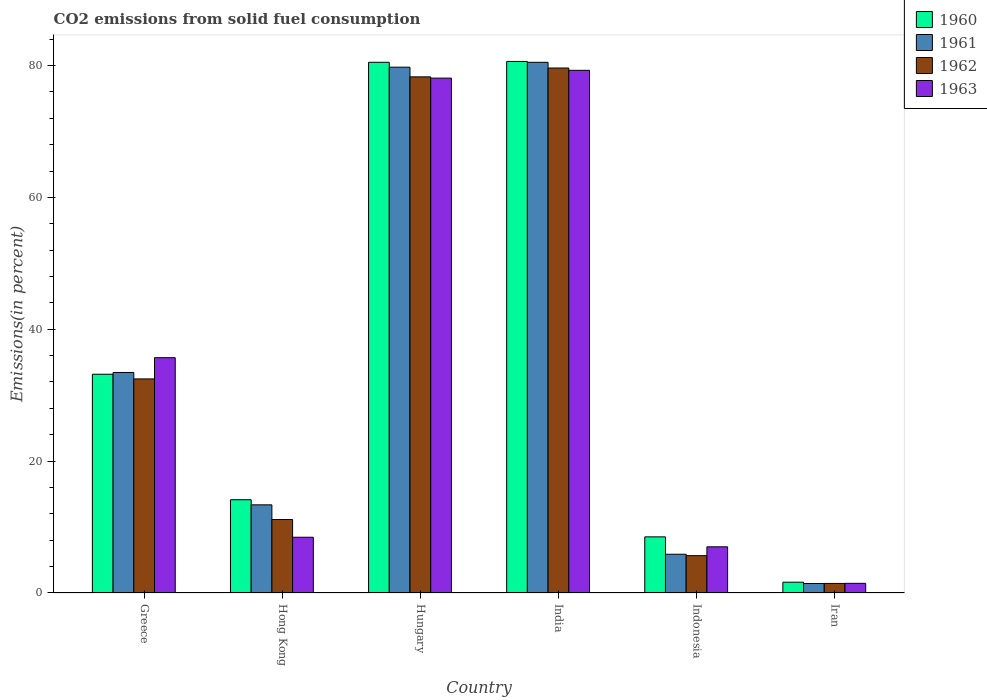How many different coloured bars are there?
Your response must be concise. 4. How many groups of bars are there?
Your response must be concise. 6. How many bars are there on the 5th tick from the left?
Your answer should be compact. 4. How many bars are there on the 5th tick from the right?
Keep it short and to the point. 4. What is the label of the 2nd group of bars from the left?
Give a very brief answer. Hong Kong. In how many cases, is the number of bars for a given country not equal to the number of legend labels?
Give a very brief answer. 0. What is the total CO2 emitted in 1962 in Hungary?
Make the answer very short. 78.28. Across all countries, what is the maximum total CO2 emitted in 1961?
Your response must be concise. 80.49. Across all countries, what is the minimum total CO2 emitted in 1963?
Offer a terse response. 1.46. In which country was the total CO2 emitted in 1962 minimum?
Your answer should be compact. Iran. What is the total total CO2 emitted in 1961 in the graph?
Provide a succinct answer. 214.36. What is the difference between the total CO2 emitted in 1960 in Greece and that in Hungary?
Keep it short and to the point. -47.31. What is the difference between the total CO2 emitted in 1961 in Iran and the total CO2 emitted in 1962 in Greece?
Make the answer very short. -31.03. What is the average total CO2 emitted in 1962 per country?
Your response must be concise. 34.77. What is the difference between the total CO2 emitted of/in 1960 and total CO2 emitted of/in 1961 in Greece?
Your response must be concise. -0.27. In how many countries, is the total CO2 emitted in 1962 greater than 28 %?
Provide a succinct answer. 3. What is the ratio of the total CO2 emitted in 1961 in Hungary to that in Iran?
Give a very brief answer. 55.57. Is the total CO2 emitted in 1961 in Greece less than that in Iran?
Keep it short and to the point. No. What is the difference between the highest and the second highest total CO2 emitted in 1963?
Your answer should be compact. -42.4. What is the difference between the highest and the lowest total CO2 emitted in 1963?
Ensure brevity in your answer.  77.81. In how many countries, is the total CO2 emitted in 1960 greater than the average total CO2 emitted in 1960 taken over all countries?
Provide a short and direct response. 2. Is it the case that in every country, the sum of the total CO2 emitted in 1960 and total CO2 emitted in 1962 is greater than the sum of total CO2 emitted in 1961 and total CO2 emitted in 1963?
Your response must be concise. No. What does the 1st bar from the left in India represents?
Make the answer very short. 1960. Is it the case that in every country, the sum of the total CO2 emitted in 1960 and total CO2 emitted in 1962 is greater than the total CO2 emitted in 1961?
Your response must be concise. Yes. How many bars are there?
Offer a terse response. 24. Are all the bars in the graph horizontal?
Offer a very short reply. No. How many countries are there in the graph?
Give a very brief answer. 6. Does the graph contain any zero values?
Offer a very short reply. No. Does the graph contain grids?
Your response must be concise. No. How many legend labels are there?
Offer a very short reply. 4. What is the title of the graph?
Your answer should be compact. CO2 emissions from solid fuel consumption. What is the label or title of the X-axis?
Provide a short and direct response. Country. What is the label or title of the Y-axis?
Offer a terse response. Emissions(in percent). What is the Emissions(in percent) of 1960 in Greece?
Keep it short and to the point. 33.18. What is the Emissions(in percent) of 1961 in Greece?
Provide a succinct answer. 33.45. What is the Emissions(in percent) in 1962 in Greece?
Offer a very short reply. 32.47. What is the Emissions(in percent) in 1963 in Greece?
Provide a short and direct response. 35.69. What is the Emissions(in percent) in 1960 in Hong Kong?
Your answer should be compact. 14.14. What is the Emissions(in percent) in 1961 in Hong Kong?
Give a very brief answer. 13.37. What is the Emissions(in percent) of 1962 in Hong Kong?
Provide a succinct answer. 11.14. What is the Emissions(in percent) of 1963 in Hong Kong?
Make the answer very short. 8.46. What is the Emissions(in percent) in 1960 in Hungary?
Offer a very short reply. 80.49. What is the Emissions(in percent) in 1961 in Hungary?
Make the answer very short. 79.75. What is the Emissions(in percent) in 1962 in Hungary?
Give a very brief answer. 78.28. What is the Emissions(in percent) in 1963 in Hungary?
Offer a terse response. 78.09. What is the Emissions(in percent) of 1960 in India?
Offer a terse response. 80.62. What is the Emissions(in percent) in 1961 in India?
Offer a very short reply. 80.49. What is the Emissions(in percent) of 1962 in India?
Your answer should be compact. 79.62. What is the Emissions(in percent) of 1963 in India?
Provide a succinct answer. 79.27. What is the Emissions(in percent) of 1960 in Indonesia?
Your answer should be compact. 8.51. What is the Emissions(in percent) of 1961 in Indonesia?
Offer a terse response. 5.88. What is the Emissions(in percent) of 1962 in Indonesia?
Offer a terse response. 5.66. What is the Emissions(in percent) of 1963 in Indonesia?
Offer a terse response. 7. What is the Emissions(in percent) in 1960 in Iran?
Provide a succinct answer. 1.64. What is the Emissions(in percent) of 1961 in Iran?
Your answer should be compact. 1.44. What is the Emissions(in percent) in 1962 in Iran?
Your answer should be compact. 1.45. What is the Emissions(in percent) of 1963 in Iran?
Offer a terse response. 1.46. Across all countries, what is the maximum Emissions(in percent) of 1960?
Your answer should be very brief. 80.62. Across all countries, what is the maximum Emissions(in percent) of 1961?
Provide a succinct answer. 80.49. Across all countries, what is the maximum Emissions(in percent) in 1962?
Your response must be concise. 79.62. Across all countries, what is the maximum Emissions(in percent) in 1963?
Give a very brief answer. 79.27. Across all countries, what is the minimum Emissions(in percent) of 1960?
Offer a very short reply. 1.64. Across all countries, what is the minimum Emissions(in percent) in 1961?
Your response must be concise. 1.44. Across all countries, what is the minimum Emissions(in percent) of 1962?
Make the answer very short. 1.45. Across all countries, what is the minimum Emissions(in percent) of 1963?
Offer a very short reply. 1.46. What is the total Emissions(in percent) in 1960 in the graph?
Offer a very short reply. 218.58. What is the total Emissions(in percent) in 1961 in the graph?
Your answer should be compact. 214.36. What is the total Emissions(in percent) of 1962 in the graph?
Your response must be concise. 208.62. What is the total Emissions(in percent) in 1963 in the graph?
Provide a succinct answer. 209.97. What is the difference between the Emissions(in percent) of 1960 in Greece and that in Hong Kong?
Your response must be concise. 19.03. What is the difference between the Emissions(in percent) of 1961 in Greece and that in Hong Kong?
Offer a terse response. 20.08. What is the difference between the Emissions(in percent) in 1962 in Greece and that in Hong Kong?
Your answer should be compact. 21.32. What is the difference between the Emissions(in percent) in 1963 in Greece and that in Hong Kong?
Provide a short and direct response. 27.23. What is the difference between the Emissions(in percent) in 1960 in Greece and that in Hungary?
Provide a succinct answer. -47.31. What is the difference between the Emissions(in percent) of 1961 in Greece and that in Hungary?
Keep it short and to the point. -46.3. What is the difference between the Emissions(in percent) of 1962 in Greece and that in Hungary?
Your answer should be compact. -45.81. What is the difference between the Emissions(in percent) of 1963 in Greece and that in Hungary?
Your answer should be very brief. -42.4. What is the difference between the Emissions(in percent) in 1960 in Greece and that in India?
Give a very brief answer. -47.44. What is the difference between the Emissions(in percent) in 1961 in Greece and that in India?
Offer a terse response. -47.04. What is the difference between the Emissions(in percent) in 1962 in Greece and that in India?
Provide a short and direct response. -47.15. What is the difference between the Emissions(in percent) of 1963 in Greece and that in India?
Offer a terse response. -43.58. What is the difference between the Emissions(in percent) of 1960 in Greece and that in Indonesia?
Give a very brief answer. 24.66. What is the difference between the Emissions(in percent) in 1961 in Greece and that in Indonesia?
Your answer should be very brief. 27.57. What is the difference between the Emissions(in percent) in 1962 in Greece and that in Indonesia?
Offer a very short reply. 26.81. What is the difference between the Emissions(in percent) in 1963 in Greece and that in Indonesia?
Provide a short and direct response. 28.69. What is the difference between the Emissions(in percent) of 1960 in Greece and that in Iran?
Your answer should be compact. 31.54. What is the difference between the Emissions(in percent) of 1961 in Greece and that in Iran?
Ensure brevity in your answer.  32.01. What is the difference between the Emissions(in percent) in 1962 in Greece and that in Iran?
Provide a short and direct response. 31.02. What is the difference between the Emissions(in percent) in 1963 in Greece and that in Iran?
Provide a succinct answer. 34.22. What is the difference between the Emissions(in percent) in 1960 in Hong Kong and that in Hungary?
Your answer should be very brief. -66.35. What is the difference between the Emissions(in percent) in 1961 in Hong Kong and that in Hungary?
Provide a short and direct response. -66.38. What is the difference between the Emissions(in percent) of 1962 in Hong Kong and that in Hungary?
Offer a terse response. -67.13. What is the difference between the Emissions(in percent) in 1963 in Hong Kong and that in Hungary?
Ensure brevity in your answer.  -69.63. What is the difference between the Emissions(in percent) in 1960 in Hong Kong and that in India?
Offer a terse response. -66.47. What is the difference between the Emissions(in percent) in 1961 in Hong Kong and that in India?
Offer a very short reply. -67.12. What is the difference between the Emissions(in percent) in 1962 in Hong Kong and that in India?
Keep it short and to the point. -68.47. What is the difference between the Emissions(in percent) in 1963 in Hong Kong and that in India?
Make the answer very short. -70.82. What is the difference between the Emissions(in percent) of 1960 in Hong Kong and that in Indonesia?
Offer a terse response. 5.63. What is the difference between the Emissions(in percent) of 1961 in Hong Kong and that in Indonesia?
Your answer should be very brief. 7.49. What is the difference between the Emissions(in percent) of 1962 in Hong Kong and that in Indonesia?
Make the answer very short. 5.48. What is the difference between the Emissions(in percent) of 1963 in Hong Kong and that in Indonesia?
Provide a succinct answer. 1.45. What is the difference between the Emissions(in percent) in 1960 in Hong Kong and that in Iran?
Give a very brief answer. 12.51. What is the difference between the Emissions(in percent) in 1961 in Hong Kong and that in Iran?
Ensure brevity in your answer.  11.93. What is the difference between the Emissions(in percent) of 1962 in Hong Kong and that in Iran?
Offer a very short reply. 9.7. What is the difference between the Emissions(in percent) in 1963 in Hong Kong and that in Iran?
Your answer should be very brief. 6.99. What is the difference between the Emissions(in percent) of 1960 in Hungary and that in India?
Provide a short and direct response. -0.13. What is the difference between the Emissions(in percent) of 1961 in Hungary and that in India?
Make the answer very short. -0.74. What is the difference between the Emissions(in percent) in 1962 in Hungary and that in India?
Offer a terse response. -1.34. What is the difference between the Emissions(in percent) in 1963 in Hungary and that in India?
Keep it short and to the point. -1.18. What is the difference between the Emissions(in percent) in 1960 in Hungary and that in Indonesia?
Make the answer very short. 71.98. What is the difference between the Emissions(in percent) of 1961 in Hungary and that in Indonesia?
Keep it short and to the point. 73.87. What is the difference between the Emissions(in percent) of 1962 in Hungary and that in Indonesia?
Offer a terse response. 72.62. What is the difference between the Emissions(in percent) in 1963 in Hungary and that in Indonesia?
Your answer should be very brief. 71.09. What is the difference between the Emissions(in percent) in 1960 in Hungary and that in Iran?
Your response must be concise. 78.85. What is the difference between the Emissions(in percent) in 1961 in Hungary and that in Iran?
Your response must be concise. 78.31. What is the difference between the Emissions(in percent) in 1962 in Hungary and that in Iran?
Keep it short and to the point. 76.83. What is the difference between the Emissions(in percent) of 1963 in Hungary and that in Iran?
Give a very brief answer. 76.62. What is the difference between the Emissions(in percent) in 1960 in India and that in Indonesia?
Offer a terse response. 72.1. What is the difference between the Emissions(in percent) of 1961 in India and that in Indonesia?
Your response must be concise. 74.61. What is the difference between the Emissions(in percent) of 1962 in India and that in Indonesia?
Your answer should be compact. 73.96. What is the difference between the Emissions(in percent) in 1963 in India and that in Indonesia?
Provide a short and direct response. 72.27. What is the difference between the Emissions(in percent) of 1960 in India and that in Iran?
Offer a very short reply. 78.98. What is the difference between the Emissions(in percent) in 1961 in India and that in Iran?
Keep it short and to the point. 79.05. What is the difference between the Emissions(in percent) in 1962 in India and that in Iran?
Offer a terse response. 78.17. What is the difference between the Emissions(in percent) of 1963 in India and that in Iran?
Offer a terse response. 77.81. What is the difference between the Emissions(in percent) of 1960 in Indonesia and that in Iran?
Your response must be concise. 6.88. What is the difference between the Emissions(in percent) of 1961 in Indonesia and that in Iran?
Your answer should be very brief. 4.44. What is the difference between the Emissions(in percent) in 1962 in Indonesia and that in Iran?
Your answer should be very brief. 4.21. What is the difference between the Emissions(in percent) in 1963 in Indonesia and that in Iran?
Offer a very short reply. 5.54. What is the difference between the Emissions(in percent) in 1960 in Greece and the Emissions(in percent) in 1961 in Hong Kong?
Offer a very short reply. 19.81. What is the difference between the Emissions(in percent) of 1960 in Greece and the Emissions(in percent) of 1962 in Hong Kong?
Ensure brevity in your answer.  22.03. What is the difference between the Emissions(in percent) in 1960 in Greece and the Emissions(in percent) in 1963 in Hong Kong?
Ensure brevity in your answer.  24.72. What is the difference between the Emissions(in percent) in 1961 in Greece and the Emissions(in percent) in 1962 in Hong Kong?
Your response must be concise. 22.3. What is the difference between the Emissions(in percent) in 1961 in Greece and the Emissions(in percent) in 1963 in Hong Kong?
Provide a short and direct response. 24.99. What is the difference between the Emissions(in percent) in 1962 in Greece and the Emissions(in percent) in 1963 in Hong Kong?
Keep it short and to the point. 24.01. What is the difference between the Emissions(in percent) of 1960 in Greece and the Emissions(in percent) of 1961 in Hungary?
Your answer should be very brief. -46.57. What is the difference between the Emissions(in percent) in 1960 in Greece and the Emissions(in percent) in 1962 in Hungary?
Give a very brief answer. -45.1. What is the difference between the Emissions(in percent) of 1960 in Greece and the Emissions(in percent) of 1963 in Hungary?
Offer a very short reply. -44.91. What is the difference between the Emissions(in percent) of 1961 in Greece and the Emissions(in percent) of 1962 in Hungary?
Make the answer very short. -44.83. What is the difference between the Emissions(in percent) in 1961 in Greece and the Emissions(in percent) in 1963 in Hungary?
Make the answer very short. -44.64. What is the difference between the Emissions(in percent) of 1962 in Greece and the Emissions(in percent) of 1963 in Hungary?
Keep it short and to the point. -45.62. What is the difference between the Emissions(in percent) in 1960 in Greece and the Emissions(in percent) in 1961 in India?
Offer a very short reply. -47.31. What is the difference between the Emissions(in percent) of 1960 in Greece and the Emissions(in percent) of 1962 in India?
Your answer should be compact. -46.44. What is the difference between the Emissions(in percent) in 1960 in Greece and the Emissions(in percent) in 1963 in India?
Ensure brevity in your answer.  -46.09. What is the difference between the Emissions(in percent) of 1961 in Greece and the Emissions(in percent) of 1962 in India?
Provide a succinct answer. -46.17. What is the difference between the Emissions(in percent) in 1961 in Greece and the Emissions(in percent) in 1963 in India?
Offer a terse response. -45.83. What is the difference between the Emissions(in percent) in 1962 in Greece and the Emissions(in percent) in 1963 in India?
Offer a terse response. -46.8. What is the difference between the Emissions(in percent) in 1960 in Greece and the Emissions(in percent) in 1961 in Indonesia?
Your answer should be compact. 27.3. What is the difference between the Emissions(in percent) in 1960 in Greece and the Emissions(in percent) in 1962 in Indonesia?
Offer a terse response. 27.52. What is the difference between the Emissions(in percent) of 1960 in Greece and the Emissions(in percent) of 1963 in Indonesia?
Offer a very short reply. 26.18. What is the difference between the Emissions(in percent) in 1961 in Greece and the Emissions(in percent) in 1962 in Indonesia?
Offer a very short reply. 27.78. What is the difference between the Emissions(in percent) in 1961 in Greece and the Emissions(in percent) in 1963 in Indonesia?
Provide a succinct answer. 26.44. What is the difference between the Emissions(in percent) in 1962 in Greece and the Emissions(in percent) in 1963 in Indonesia?
Provide a short and direct response. 25.47. What is the difference between the Emissions(in percent) in 1960 in Greece and the Emissions(in percent) in 1961 in Iran?
Offer a terse response. 31.74. What is the difference between the Emissions(in percent) in 1960 in Greece and the Emissions(in percent) in 1962 in Iran?
Keep it short and to the point. 31.73. What is the difference between the Emissions(in percent) of 1960 in Greece and the Emissions(in percent) of 1963 in Iran?
Your response must be concise. 31.71. What is the difference between the Emissions(in percent) of 1961 in Greece and the Emissions(in percent) of 1962 in Iran?
Offer a very short reply. 32. What is the difference between the Emissions(in percent) of 1961 in Greece and the Emissions(in percent) of 1963 in Iran?
Ensure brevity in your answer.  31.98. What is the difference between the Emissions(in percent) in 1962 in Greece and the Emissions(in percent) in 1963 in Iran?
Make the answer very short. 31. What is the difference between the Emissions(in percent) of 1960 in Hong Kong and the Emissions(in percent) of 1961 in Hungary?
Provide a short and direct response. -65.6. What is the difference between the Emissions(in percent) in 1960 in Hong Kong and the Emissions(in percent) in 1962 in Hungary?
Your answer should be very brief. -64.13. What is the difference between the Emissions(in percent) in 1960 in Hong Kong and the Emissions(in percent) in 1963 in Hungary?
Your response must be concise. -63.94. What is the difference between the Emissions(in percent) of 1961 in Hong Kong and the Emissions(in percent) of 1962 in Hungary?
Make the answer very short. -64.91. What is the difference between the Emissions(in percent) in 1961 in Hong Kong and the Emissions(in percent) in 1963 in Hungary?
Ensure brevity in your answer.  -64.72. What is the difference between the Emissions(in percent) in 1962 in Hong Kong and the Emissions(in percent) in 1963 in Hungary?
Ensure brevity in your answer.  -66.94. What is the difference between the Emissions(in percent) in 1960 in Hong Kong and the Emissions(in percent) in 1961 in India?
Your answer should be very brief. -66.34. What is the difference between the Emissions(in percent) of 1960 in Hong Kong and the Emissions(in percent) of 1962 in India?
Offer a terse response. -65.47. What is the difference between the Emissions(in percent) in 1960 in Hong Kong and the Emissions(in percent) in 1963 in India?
Your response must be concise. -65.13. What is the difference between the Emissions(in percent) in 1961 in Hong Kong and the Emissions(in percent) in 1962 in India?
Offer a terse response. -66.25. What is the difference between the Emissions(in percent) of 1961 in Hong Kong and the Emissions(in percent) of 1963 in India?
Offer a very short reply. -65.9. What is the difference between the Emissions(in percent) of 1962 in Hong Kong and the Emissions(in percent) of 1963 in India?
Ensure brevity in your answer.  -68.13. What is the difference between the Emissions(in percent) in 1960 in Hong Kong and the Emissions(in percent) in 1961 in Indonesia?
Provide a succinct answer. 8.27. What is the difference between the Emissions(in percent) of 1960 in Hong Kong and the Emissions(in percent) of 1962 in Indonesia?
Offer a very short reply. 8.48. What is the difference between the Emissions(in percent) of 1960 in Hong Kong and the Emissions(in percent) of 1963 in Indonesia?
Your answer should be very brief. 7.14. What is the difference between the Emissions(in percent) of 1961 in Hong Kong and the Emissions(in percent) of 1962 in Indonesia?
Make the answer very short. 7.71. What is the difference between the Emissions(in percent) of 1961 in Hong Kong and the Emissions(in percent) of 1963 in Indonesia?
Your answer should be compact. 6.37. What is the difference between the Emissions(in percent) in 1962 in Hong Kong and the Emissions(in percent) in 1963 in Indonesia?
Give a very brief answer. 4.14. What is the difference between the Emissions(in percent) in 1960 in Hong Kong and the Emissions(in percent) in 1961 in Iran?
Your answer should be compact. 12.71. What is the difference between the Emissions(in percent) of 1960 in Hong Kong and the Emissions(in percent) of 1962 in Iran?
Offer a terse response. 12.7. What is the difference between the Emissions(in percent) of 1960 in Hong Kong and the Emissions(in percent) of 1963 in Iran?
Provide a succinct answer. 12.68. What is the difference between the Emissions(in percent) in 1961 in Hong Kong and the Emissions(in percent) in 1962 in Iran?
Provide a short and direct response. 11.92. What is the difference between the Emissions(in percent) in 1961 in Hong Kong and the Emissions(in percent) in 1963 in Iran?
Your answer should be compact. 11.91. What is the difference between the Emissions(in percent) of 1962 in Hong Kong and the Emissions(in percent) of 1963 in Iran?
Ensure brevity in your answer.  9.68. What is the difference between the Emissions(in percent) of 1960 in Hungary and the Emissions(in percent) of 1961 in India?
Your response must be concise. 0. What is the difference between the Emissions(in percent) of 1960 in Hungary and the Emissions(in percent) of 1962 in India?
Offer a terse response. 0.87. What is the difference between the Emissions(in percent) of 1960 in Hungary and the Emissions(in percent) of 1963 in India?
Offer a terse response. 1.22. What is the difference between the Emissions(in percent) of 1961 in Hungary and the Emissions(in percent) of 1962 in India?
Your response must be concise. 0.13. What is the difference between the Emissions(in percent) in 1961 in Hungary and the Emissions(in percent) in 1963 in India?
Your answer should be compact. 0.48. What is the difference between the Emissions(in percent) in 1962 in Hungary and the Emissions(in percent) in 1963 in India?
Give a very brief answer. -0.99. What is the difference between the Emissions(in percent) of 1960 in Hungary and the Emissions(in percent) of 1961 in Indonesia?
Your answer should be very brief. 74.61. What is the difference between the Emissions(in percent) of 1960 in Hungary and the Emissions(in percent) of 1962 in Indonesia?
Provide a succinct answer. 74.83. What is the difference between the Emissions(in percent) in 1960 in Hungary and the Emissions(in percent) in 1963 in Indonesia?
Give a very brief answer. 73.49. What is the difference between the Emissions(in percent) in 1961 in Hungary and the Emissions(in percent) in 1962 in Indonesia?
Ensure brevity in your answer.  74.09. What is the difference between the Emissions(in percent) of 1961 in Hungary and the Emissions(in percent) of 1963 in Indonesia?
Your answer should be very brief. 72.75. What is the difference between the Emissions(in percent) of 1962 in Hungary and the Emissions(in percent) of 1963 in Indonesia?
Keep it short and to the point. 71.28. What is the difference between the Emissions(in percent) of 1960 in Hungary and the Emissions(in percent) of 1961 in Iran?
Your answer should be very brief. 79.05. What is the difference between the Emissions(in percent) of 1960 in Hungary and the Emissions(in percent) of 1962 in Iran?
Your answer should be compact. 79.04. What is the difference between the Emissions(in percent) in 1960 in Hungary and the Emissions(in percent) in 1963 in Iran?
Keep it short and to the point. 79.03. What is the difference between the Emissions(in percent) of 1961 in Hungary and the Emissions(in percent) of 1962 in Iran?
Your answer should be compact. 78.3. What is the difference between the Emissions(in percent) in 1961 in Hungary and the Emissions(in percent) in 1963 in Iran?
Your answer should be very brief. 78.28. What is the difference between the Emissions(in percent) in 1962 in Hungary and the Emissions(in percent) in 1963 in Iran?
Provide a succinct answer. 76.81. What is the difference between the Emissions(in percent) of 1960 in India and the Emissions(in percent) of 1961 in Indonesia?
Keep it short and to the point. 74.74. What is the difference between the Emissions(in percent) of 1960 in India and the Emissions(in percent) of 1962 in Indonesia?
Make the answer very short. 74.96. What is the difference between the Emissions(in percent) of 1960 in India and the Emissions(in percent) of 1963 in Indonesia?
Give a very brief answer. 73.61. What is the difference between the Emissions(in percent) of 1961 in India and the Emissions(in percent) of 1962 in Indonesia?
Your answer should be compact. 74.83. What is the difference between the Emissions(in percent) of 1961 in India and the Emissions(in percent) of 1963 in Indonesia?
Keep it short and to the point. 73.49. What is the difference between the Emissions(in percent) of 1962 in India and the Emissions(in percent) of 1963 in Indonesia?
Your answer should be very brief. 72.62. What is the difference between the Emissions(in percent) of 1960 in India and the Emissions(in percent) of 1961 in Iran?
Ensure brevity in your answer.  79.18. What is the difference between the Emissions(in percent) in 1960 in India and the Emissions(in percent) in 1962 in Iran?
Ensure brevity in your answer.  79.17. What is the difference between the Emissions(in percent) in 1960 in India and the Emissions(in percent) in 1963 in Iran?
Provide a succinct answer. 79.15. What is the difference between the Emissions(in percent) in 1961 in India and the Emissions(in percent) in 1962 in Iran?
Give a very brief answer. 79.04. What is the difference between the Emissions(in percent) in 1961 in India and the Emissions(in percent) in 1963 in Iran?
Offer a terse response. 79.02. What is the difference between the Emissions(in percent) in 1962 in India and the Emissions(in percent) in 1963 in Iran?
Offer a terse response. 78.16. What is the difference between the Emissions(in percent) of 1960 in Indonesia and the Emissions(in percent) of 1961 in Iran?
Offer a terse response. 7.08. What is the difference between the Emissions(in percent) in 1960 in Indonesia and the Emissions(in percent) in 1962 in Iran?
Provide a succinct answer. 7.07. What is the difference between the Emissions(in percent) of 1960 in Indonesia and the Emissions(in percent) of 1963 in Iran?
Offer a very short reply. 7.05. What is the difference between the Emissions(in percent) in 1961 in Indonesia and the Emissions(in percent) in 1962 in Iran?
Offer a terse response. 4.43. What is the difference between the Emissions(in percent) of 1961 in Indonesia and the Emissions(in percent) of 1963 in Iran?
Provide a short and direct response. 4.41. What is the difference between the Emissions(in percent) in 1962 in Indonesia and the Emissions(in percent) in 1963 in Iran?
Give a very brief answer. 4.2. What is the average Emissions(in percent) in 1960 per country?
Keep it short and to the point. 36.43. What is the average Emissions(in percent) in 1961 per country?
Offer a terse response. 35.73. What is the average Emissions(in percent) in 1962 per country?
Your answer should be compact. 34.77. What is the average Emissions(in percent) of 1963 per country?
Provide a succinct answer. 34.99. What is the difference between the Emissions(in percent) in 1960 and Emissions(in percent) in 1961 in Greece?
Provide a succinct answer. -0.27. What is the difference between the Emissions(in percent) in 1960 and Emissions(in percent) in 1962 in Greece?
Your answer should be very brief. 0.71. What is the difference between the Emissions(in percent) in 1960 and Emissions(in percent) in 1963 in Greece?
Ensure brevity in your answer.  -2.51. What is the difference between the Emissions(in percent) in 1961 and Emissions(in percent) in 1962 in Greece?
Your response must be concise. 0.98. What is the difference between the Emissions(in percent) in 1961 and Emissions(in percent) in 1963 in Greece?
Provide a short and direct response. -2.24. What is the difference between the Emissions(in percent) in 1962 and Emissions(in percent) in 1963 in Greece?
Your answer should be compact. -3.22. What is the difference between the Emissions(in percent) of 1960 and Emissions(in percent) of 1961 in Hong Kong?
Your answer should be compact. 0.77. What is the difference between the Emissions(in percent) in 1960 and Emissions(in percent) in 1962 in Hong Kong?
Your response must be concise. 3. What is the difference between the Emissions(in percent) of 1960 and Emissions(in percent) of 1963 in Hong Kong?
Offer a very short reply. 5.69. What is the difference between the Emissions(in percent) of 1961 and Emissions(in percent) of 1962 in Hong Kong?
Give a very brief answer. 2.23. What is the difference between the Emissions(in percent) of 1961 and Emissions(in percent) of 1963 in Hong Kong?
Your response must be concise. 4.91. What is the difference between the Emissions(in percent) in 1962 and Emissions(in percent) in 1963 in Hong Kong?
Your answer should be very brief. 2.69. What is the difference between the Emissions(in percent) in 1960 and Emissions(in percent) in 1961 in Hungary?
Provide a short and direct response. 0.74. What is the difference between the Emissions(in percent) of 1960 and Emissions(in percent) of 1962 in Hungary?
Your answer should be compact. 2.21. What is the difference between the Emissions(in percent) of 1960 and Emissions(in percent) of 1963 in Hungary?
Offer a very short reply. 2.4. What is the difference between the Emissions(in percent) of 1961 and Emissions(in percent) of 1962 in Hungary?
Your answer should be very brief. 1.47. What is the difference between the Emissions(in percent) in 1961 and Emissions(in percent) in 1963 in Hungary?
Your answer should be compact. 1.66. What is the difference between the Emissions(in percent) in 1962 and Emissions(in percent) in 1963 in Hungary?
Provide a short and direct response. 0.19. What is the difference between the Emissions(in percent) in 1960 and Emissions(in percent) in 1961 in India?
Offer a very short reply. 0.13. What is the difference between the Emissions(in percent) of 1960 and Emissions(in percent) of 1963 in India?
Provide a short and direct response. 1.34. What is the difference between the Emissions(in percent) of 1961 and Emissions(in percent) of 1962 in India?
Give a very brief answer. 0.87. What is the difference between the Emissions(in percent) of 1961 and Emissions(in percent) of 1963 in India?
Provide a succinct answer. 1.22. What is the difference between the Emissions(in percent) in 1962 and Emissions(in percent) in 1963 in India?
Your answer should be very brief. 0.35. What is the difference between the Emissions(in percent) of 1960 and Emissions(in percent) of 1961 in Indonesia?
Your answer should be very brief. 2.64. What is the difference between the Emissions(in percent) of 1960 and Emissions(in percent) of 1962 in Indonesia?
Offer a terse response. 2.85. What is the difference between the Emissions(in percent) in 1960 and Emissions(in percent) in 1963 in Indonesia?
Your answer should be compact. 1.51. What is the difference between the Emissions(in percent) of 1961 and Emissions(in percent) of 1962 in Indonesia?
Your answer should be very brief. 0.21. What is the difference between the Emissions(in percent) of 1961 and Emissions(in percent) of 1963 in Indonesia?
Provide a succinct answer. -1.13. What is the difference between the Emissions(in percent) in 1962 and Emissions(in percent) in 1963 in Indonesia?
Your answer should be compact. -1.34. What is the difference between the Emissions(in percent) in 1960 and Emissions(in percent) in 1961 in Iran?
Ensure brevity in your answer.  0.2. What is the difference between the Emissions(in percent) of 1960 and Emissions(in percent) of 1962 in Iran?
Offer a terse response. 0.19. What is the difference between the Emissions(in percent) in 1960 and Emissions(in percent) in 1963 in Iran?
Provide a succinct answer. 0.17. What is the difference between the Emissions(in percent) of 1961 and Emissions(in percent) of 1962 in Iran?
Ensure brevity in your answer.  -0.01. What is the difference between the Emissions(in percent) of 1961 and Emissions(in percent) of 1963 in Iran?
Offer a very short reply. -0.03. What is the difference between the Emissions(in percent) in 1962 and Emissions(in percent) in 1963 in Iran?
Your answer should be compact. -0.01. What is the ratio of the Emissions(in percent) in 1960 in Greece to that in Hong Kong?
Offer a terse response. 2.35. What is the ratio of the Emissions(in percent) of 1961 in Greece to that in Hong Kong?
Make the answer very short. 2.5. What is the ratio of the Emissions(in percent) of 1962 in Greece to that in Hong Kong?
Provide a short and direct response. 2.91. What is the ratio of the Emissions(in percent) of 1963 in Greece to that in Hong Kong?
Keep it short and to the point. 4.22. What is the ratio of the Emissions(in percent) of 1960 in Greece to that in Hungary?
Your answer should be very brief. 0.41. What is the ratio of the Emissions(in percent) of 1961 in Greece to that in Hungary?
Make the answer very short. 0.42. What is the ratio of the Emissions(in percent) in 1962 in Greece to that in Hungary?
Your answer should be very brief. 0.41. What is the ratio of the Emissions(in percent) of 1963 in Greece to that in Hungary?
Offer a terse response. 0.46. What is the ratio of the Emissions(in percent) of 1960 in Greece to that in India?
Offer a terse response. 0.41. What is the ratio of the Emissions(in percent) of 1961 in Greece to that in India?
Your answer should be compact. 0.42. What is the ratio of the Emissions(in percent) in 1962 in Greece to that in India?
Your answer should be very brief. 0.41. What is the ratio of the Emissions(in percent) in 1963 in Greece to that in India?
Offer a very short reply. 0.45. What is the ratio of the Emissions(in percent) in 1960 in Greece to that in Indonesia?
Your answer should be compact. 3.9. What is the ratio of the Emissions(in percent) in 1961 in Greece to that in Indonesia?
Your answer should be compact. 5.69. What is the ratio of the Emissions(in percent) of 1962 in Greece to that in Indonesia?
Keep it short and to the point. 5.74. What is the ratio of the Emissions(in percent) in 1963 in Greece to that in Indonesia?
Make the answer very short. 5.1. What is the ratio of the Emissions(in percent) in 1960 in Greece to that in Iran?
Make the answer very short. 20.26. What is the ratio of the Emissions(in percent) in 1961 in Greece to that in Iran?
Your answer should be compact. 23.31. What is the ratio of the Emissions(in percent) in 1962 in Greece to that in Iran?
Provide a short and direct response. 22.41. What is the ratio of the Emissions(in percent) of 1963 in Greece to that in Iran?
Ensure brevity in your answer.  24.38. What is the ratio of the Emissions(in percent) of 1960 in Hong Kong to that in Hungary?
Make the answer very short. 0.18. What is the ratio of the Emissions(in percent) of 1961 in Hong Kong to that in Hungary?
Keep it short and to the point. 0.17. What is the ratio of the Emissions(in percent) of 1962 in Hong Kong to that in Hungary?
Ensure brevity in your answer.  0.14. What is the ratio of the Emissions(in percent) of 1963 in Hong Kong to that in Hungary?
Your answer should be compact. 0.11. What is the ratio of the Emissions(in percent) in 1960 in Hong Kong to that in India?
Your answer should be compact. 0.18. What is the ratio of the Emissions(in percent) of 1961 in Hong Kong to that in India?
Offer a terse response. 0.17. What is the ratio of the Emissions(in percent) of 1962 in Hong Kong to that in India?
Your answer should be compact. 0.14. What is the ratio of the Emissions(in percent) of 1963 in Hong Kong to that in India?
Offer a very short reply. 0.11. What is the ratio of the Emissions(in percent) of 1960 in Hong Kong to that in Indonesia?
Your answer should be compact. 1.66. What is the ratio of the Emissions(in percent) of 1961 in Hong Kong to that in Indonesia?
Provide a succinct answer. 2.28. What is the ratio of the Emissions(in percent) of 1962 in Hong Kong to that in Indonesia?
Your response must be concise. 1.97. What is the ratio of the Emissions(in percent) in 1963 in Hong Kong to that in Indonesia?
Provide a short and direct response. 1.21. What is the ratio of the Emissions(in percent) of 1960 in Hong Kong to that in Iran?
Your response must be concise. 8.64. What is the ratio of the Emissions(in percent) in 1961 in Hong Kong to that in Iran?
Your answer should be very brief. 9.32. What is the ratio of the Emissions(in percent) in 1962 in Hong Kong to that in Iran?
Give a very brief answer. 7.69. What is the ratio of the Emissions(in percent) in 1963 in Hong Kong to that in Iran?
Ensure brevity in your answer.  5.78. What is the ratio of the Emissions(in percent) in 1960 in Hungary to that in India?
Your answer should be compact. 1. What is the ratio of the Emissions(in percent) of 1962 in Hungary to that in India?
Offer a terse response. 0.98. What is the ratio of the Emissions(in percent) of 1963 in Hungary to that in India?
Offer a terse response. 0.99. What is the ratio of the Emissions(in percent) of 1960 in Hungary to that in Indonesia?
Offer a terse response. 9.45. What is the ratio of the Emissions(in percent) of 1961 in Hungary to that in Indonesia?
Keep it short and to the point. 13.57. What is the ratio of the Emissions(in percent) of 1962 in Hungary to that in Indonesia?
Provide a succinct answer. 13.83. What is the ratio of the Emissions(in percent) of 1963 in Hungary to that in Indonesia?
Keep it short and to the point. 11.15. What is the ratio of the Emissions(in percent) in 1960 in Hungary to that in Iran?
Offer a terse response. 49.15. What is the ratio of the Emissions(in percent) in 1961 in Hungary to that in Iran?
Your answer should be very brief. 55.57. What is the ratio of the Emissions(in percent) of 1962 in Hungary to that in Iran?
Ensure brevity in your answer.  54.03. What is the ratio of the Emissions(in percent) of 1963 in Hungary to that in Iran?
Provide a succinct answer. 53.36. What is the ratio of the Emissions(in percent) in 1960 in India to that in Indonesia?
Your answer should be compact. 9.47. What is the ratio of the Emissions(in percent) of 1961 in India to that in Indonesia?
Make the answer very short. 13.7. What is the ratio of the Emissions(in percent) in 1962 in India to that in Indonesia?
Keep it short and to the point. 14.06. What is the ratio of the Emissions(in percent) in 1963 in India to that in Indonesia?
Provide a succinct answer. 11.32. What is the ratio of the Emissions(in percent) of 1960 in India to that in Iran?
Give a very brief answer. 49.22. What is the ratio of the Emissions(in percent) in 1961 in India to that in Iran?
Your answer should be compact. 56.09. What is the ratio of the Emissions(in percent) of 1962 in India to that in Iran?
Your response must be concise. 54.96. What is the ratio of the Emissions(in percent) in 1963 in India to that in Iran?
Provide a short and direct response. 54.16. What is the ratio of the Emissions(in percent) in 1960 in Indonesia to that in Iran?
Give a very brief answer. 5.2. What is the ratio of the Emissions(in percent) of 1961 in Indonesia to that in Iran?
Your answer should be very brief. 4.09. What is the ratio of the Emissions(in percent) in 1962 in Indonesia to that in Iran?
Ensure brevity in your answer.  3.91. What is the ratio of the Emissions(in percent) of 1963 in Indonesia to that in Iran?
Offer a terse response. 4.78. What is the difference between the highest and the second highest Emissions(in percent) in 1960?
Your answer should be very brief. 0.13. What is the difference between the highest and the second highest Emissions(in percent) in 1961?
Your response must be concise. 0.74. What is the difference between the highest and the second highest Emissions(in percent) of 1962?
Keep it short and to the point. 1.34. What is the difference between the highest and the second highest Emissions(in percent) in 1963?
Your response must be concise. 1.18. What is the difference between the highest and the lowest Emissions(in percent) of 1960?
Offer a terse response. 78.98. What is the difference between the highest and the lowest Emissions(in percent) of 1961?
Offer a terse response. 79.05. What is the difference between the highest and the lowest Emissions(in percent) of 1962?
Provide a succinct answer. 78.17. What is the difference between the highest and the lowest Emissions(in percent) of 1963?
Give a very brief answer. 77.81. 